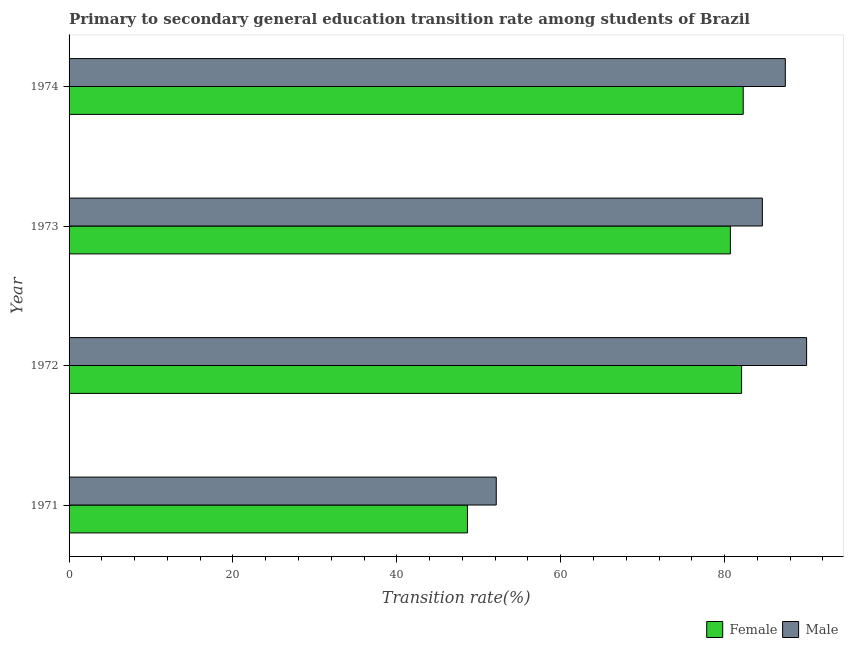How many different coloured bars are there?
Give a very brief answer. 2. How many groups of bars are there?
Your answer should be compact. 4. How many bars are there on the 2nd tick from the top?
Your response must be concise. 2. In how many cases, is the number of bars for a given year not equal to the number of legend labels?
Provide a succinct answer. 0. What is the transition rate among male students in 1971?
Offer a terse response. 52.13. Across all years, what is the maximum transition rate among male students?
Offer a terse response. 90.01. Across all years, what is the minimum transition rate among male students?
Give a very brief answer. 52.13. In which year was the transition rate among female students maximum?
Offer a terse response. 1974. What is the total transition rate among female students in the graph?
Provide a succinct answer. 293.67. What is the difference between the transition rate among female students in 1972 and that in 1973?
Offer a very short reply. 1.37. What is the difference between the transition rate among male students in 1971 and the transition rate among female students in 1972?
Offer a very short reply. -29.94. What is the average transition rate among female students per year?
Provide a short and direct response. 73.42. In the year 1972, what is the difference between the transition rate among female students and transition rate among male students?
Offer a terse response. -7.93. In how many years, is the transition rate among female students greater than 48 %?
Provide a short and direct response. 4. What is the ratio of the transition rate among male students in 1971 to that in 1972?
Your answer should be very brief. 0.58. Is the transition rate among male students in 1972 less than that in 1974?
Keep it short and to the point. No. Is the difference between the transition rate among male students in 1972 and 1973 greater than the difference between the transition rate among female students in 1972 and 1973?
Offer a very short reply. Yes. What is the difference between the highest and the second highest transition rate among female students?
Offer a very short reply. 0.2. What is the difference between the highest and the lowest transition rate among male students?
Ensure brevity in your answer.  37.88. What does the 1st bar from the top in 1972 represents?
Your answer should be compact. Male. How many bars are there?
Provide a short and direct response. 8. Are all the bars in the graph horizontal?
Provide a succinct answer. Yes. How many years are there in the graph?
Your answer should be very brief. 4. What is the difference between two consecutive major ticks on the X-axis?
Provide a succinct answer. 20. Does the graph contain grids?
Offer a very short reply. No. How many legend labels are there?
Keep it short and to the point. 2. What is the title of the graph?
Offer a very short reply. Primary to secondary general education transition rate among students of Brazil. What is the label or title of the X-axis?
Offer a terse response. Transition rate(%). What is the Transition rate(%) of Female in 1971?
Keep it short and to the point. 48.62. What is the Transition rate(%) in Male in 1971?
Make the answer very short. 52.13. What is the Transition rate(%) in Female in 1972?
Provide a short and direct response. 82.08. What is the Transition rate(%) in Male in 1972?
Keep it short and to the point. 90.01. What is the Transition rate(%) in Female in 1973?
Ensure brevity in your answer.  80.71. What is the Transition rate(%) in Male in 1973?
Your answer should be very brief. 84.61. What is the Transition rate(%) of Female in 1974?
Provide a short and direct response. 82.27. What is the Transition rate(%) in Male in 1974?
Make the answer very short. 87.41. Across all years, what is the maximum Transition rate(%) of Female?
Provide a succinct answer. 82.27. Across all years, what is the maximum Transition rate(%) of Male?
Ensure brevity in your answer.  90.01. Across all years, what is the minimum Transition rate(%) in Female?
Your response must be concise. 48.62. Across all years, what is the minimum Transition rate(%) of Male?
Your answer should be compact. 52.13. What is the total Transition rate(%) in Female in the graph?
Give a very brief answer. 293.67. What is the total Transition rate(%) of Male in the graph?
Offer a terse response. 314.16. What is the difference between the Transition rate(%) in Female in 1971 and that in 1972?
Your response must be concise. -33.46. What is the difference between the Transition rate(%) of Male in 1971 and that in 1972?
Keep it short and to the point. -37.88. What is the difference between the Transition rate(%) of Female in 1971 and that in 1973?
Your answer should be compact. -32.09. What is the difference between the Transition rate(%) of Male in 1971 and that in 1973?
Ensure brevity in your answer.  -32.48. What is the difference between the Transition rate(%) in Female in 1971 and that in 1974?
Your answer should be compact. -33.66. What is the difference between the Transition rate(%) of Male in 1971 and that in 1974?
Make the answer very short. -35.28. What is the difference between the Transition rate(%) of Female in 1972 and that in 1973?
Give a very brief answer. 1.37. What is the difference between the Transition rate(%) in Male in 1972 and that in 1973?
Keep it short and to the point. 5.4. What is the difference between the Transition rate(%) in Female in 1972 and that in 1974?
Offer a terse response. -0.2. What is the difference between the Transition rate(%) in Female in 1973 and that in 1974?
Make the answer very short. -1.57. What is the difference between the Transition rate(%) of Male in 1973 and that in 1974?
Ensure brevity in your answer.  -2.8. What is the difference between the Transition rate(%) in Female in 1971 and the Transition rate(%) in Male in 1972?
Keep it short and to the point. -41.39. What is the difference between the Transition rate(%) of Female in 1971 and the Transition rate(%) of Male in 1973?
Make the answer very short. -35.99. What is the difference between the Transition rate(%) of Female in 1971 and the Transition rate(%) of Male in 1974?
Keep it short and to the point. -38.79. What is the difference between the Transition rate(%) of Female in 1972 and the Transition rate(%) of Male in 1973?
Offer a very short reply. -2.53. What is the difference between the Transition rate(%) in Female in 1972 and the Transition rate(%) in Male in 1974?
Your answer should be compact. -5.34. What is the difference between the Transition rate(%) in Female in 1973 and the Transition rate(%) in Male in 1974?
Your answer should be very brief. -6.7. What is the average Transition rate(%) in Female per year?
Offer a terse response. 73.42. What is the average Transition rate(%) in Male per year?
Your answer should be very brief. 78.54. In the year 1971, what is the difference between the Transition rate(%) of Female and Transition rate(%) of Male?
Your response must be concise. -3.51. In the year 1972, what is the difference between the Transition rate(%) of Female and Transition rate(%) of Male?
Your answer should be compact. -7.94. In the year 1973, what is the difference between the Transition rate(%) of Female and Transition rate(%) of Male?
Provide a succinct answer. -3.9. In the year 1974, what is the difference between the Transition rate(%) of Female and Transition rate(%) of Male?
Make the answer very short. -5.14. What is the ratio of the Transition rate(%) in Female in 1971 to that in 1972?
Keep it short and to the point. 0.59. What is the ratio of the Transition rate(%) of Male in 1971 to that in 1972?
Provide a succinct answer. 0.58. What is the ratio of the Transition rate(%) in Female in 1971 to that in 1973?
Your answer should be compact. 0.6. What is the ratio of the Transition rate(%) in Male in 1971 to that in 1973?
Give a very brief answer. 0.62. What is the ratio of the Transition rate(%) of Female in 1971 to that in 1974?
Provide a short and direct response. 0.59. What is the ratio of the Transition rate(%) in Male in 1971 to that in 1974?
Keep it short and to the point. 0.6. What is the ratio of the Transition rate(%) of Female in 1972 to that in 1973?
Provide a short and direct response. 1.02. What is the ratio of the Transition rate(%) in Male in 1972 to that in 1973?
Make the answer very short. 1.06. What is the ratio of the Transition rate(%) in Female in 1972 to that in 1974?
Give a very brief answer. 1. What is the ratio of the Transition rate(%) in Male in 1972 to that in 1974?
Ensure brevity in your answer.  1.03. What is the difference between the highest and the second highest Transition rate(%) of Female?
Give a very brief answer. 0.2. What is the difference between the highest and the second highest Transition rate(%) in Male?
Your response must be concise. 2.6. What is the difference between the highest and the lowest Transition rate(%) in Female?
Provide a succinct answer. 33.66. What is the difference between the highest and the lowest Transition rate(%) in Male?
Give a very brief answer. 37.88. 